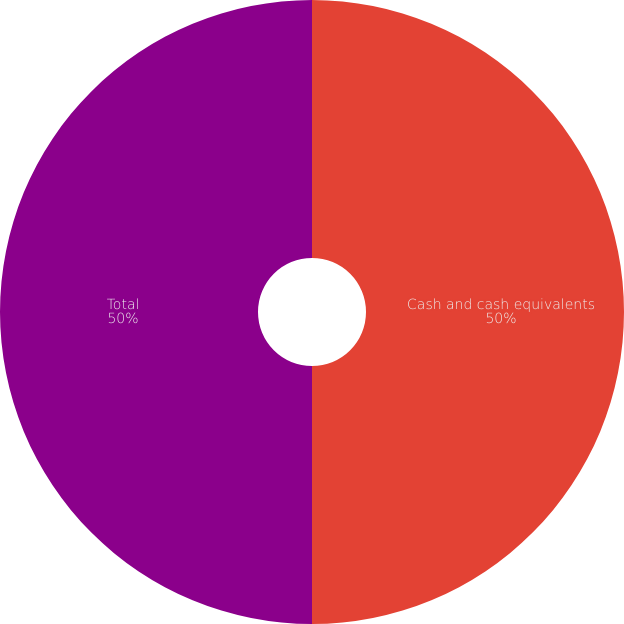<chart> <loc_0><loc_0><loc_500><loc_500><pie_chart><fcel>Cash and cash equivalents<fcel>Total<nl><fcel>50.0%<fcel>50.0%<nl></chart> 